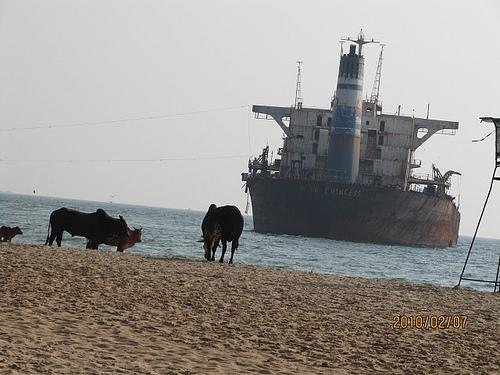How many cows are sniffing around on the beach front? Please explain your reasoning. four. One cow is in the center of the image, two more overlap to the left and a final one is in the far left of the image. 